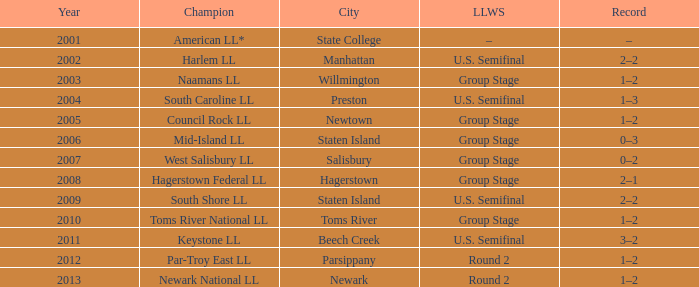Which Little League World Series took place in Parsippany? Round 2. 